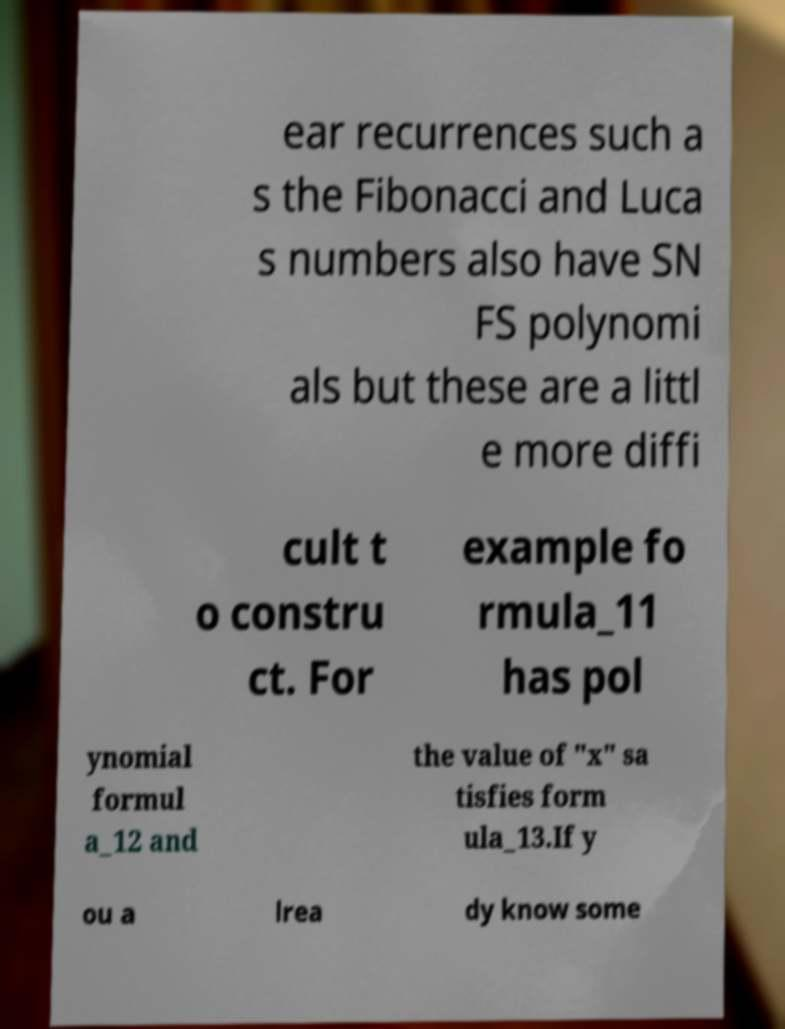What messages or text are displayed in this image? I need them in a readable, typed format. ear recurrences such a s the Fibonacci and Luca s numbers also have SN FS polynomi als but these are a littl e more diffi cult t o constru ct. For example fo rmula_11 has pol ynomial formul a_12 and the value of "x" sa tisfies form ula_13.If y ou a lrea dy know some 